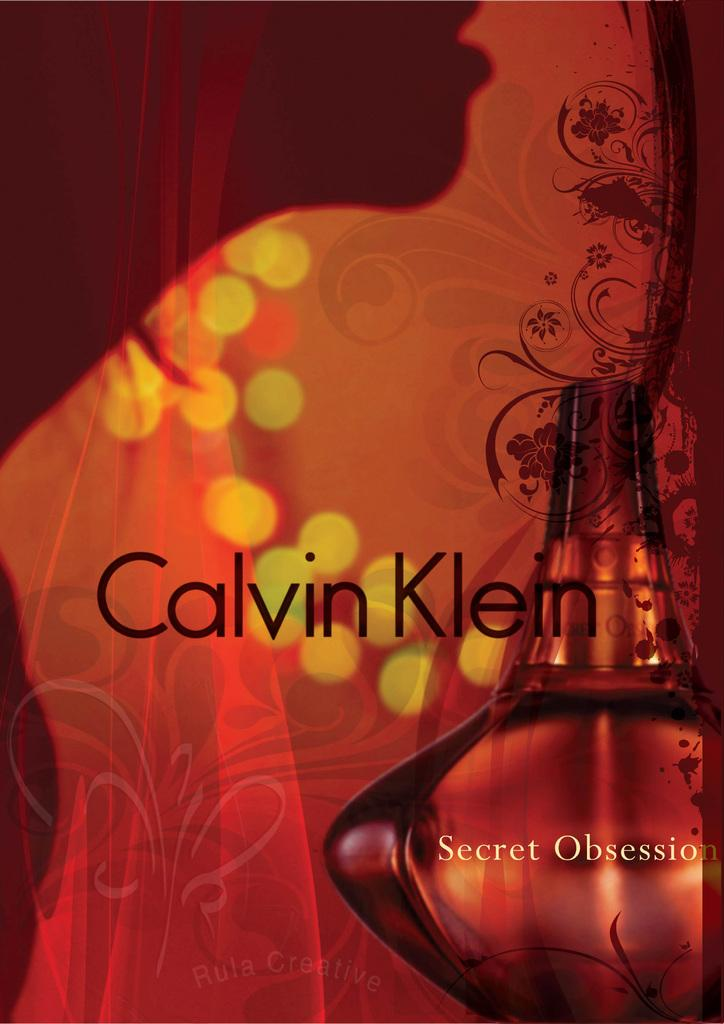<image>
Present a compact description of the photo's key features. A silhouette of a woman standing over a bottle of Calvin Klein Secret Obsession. 